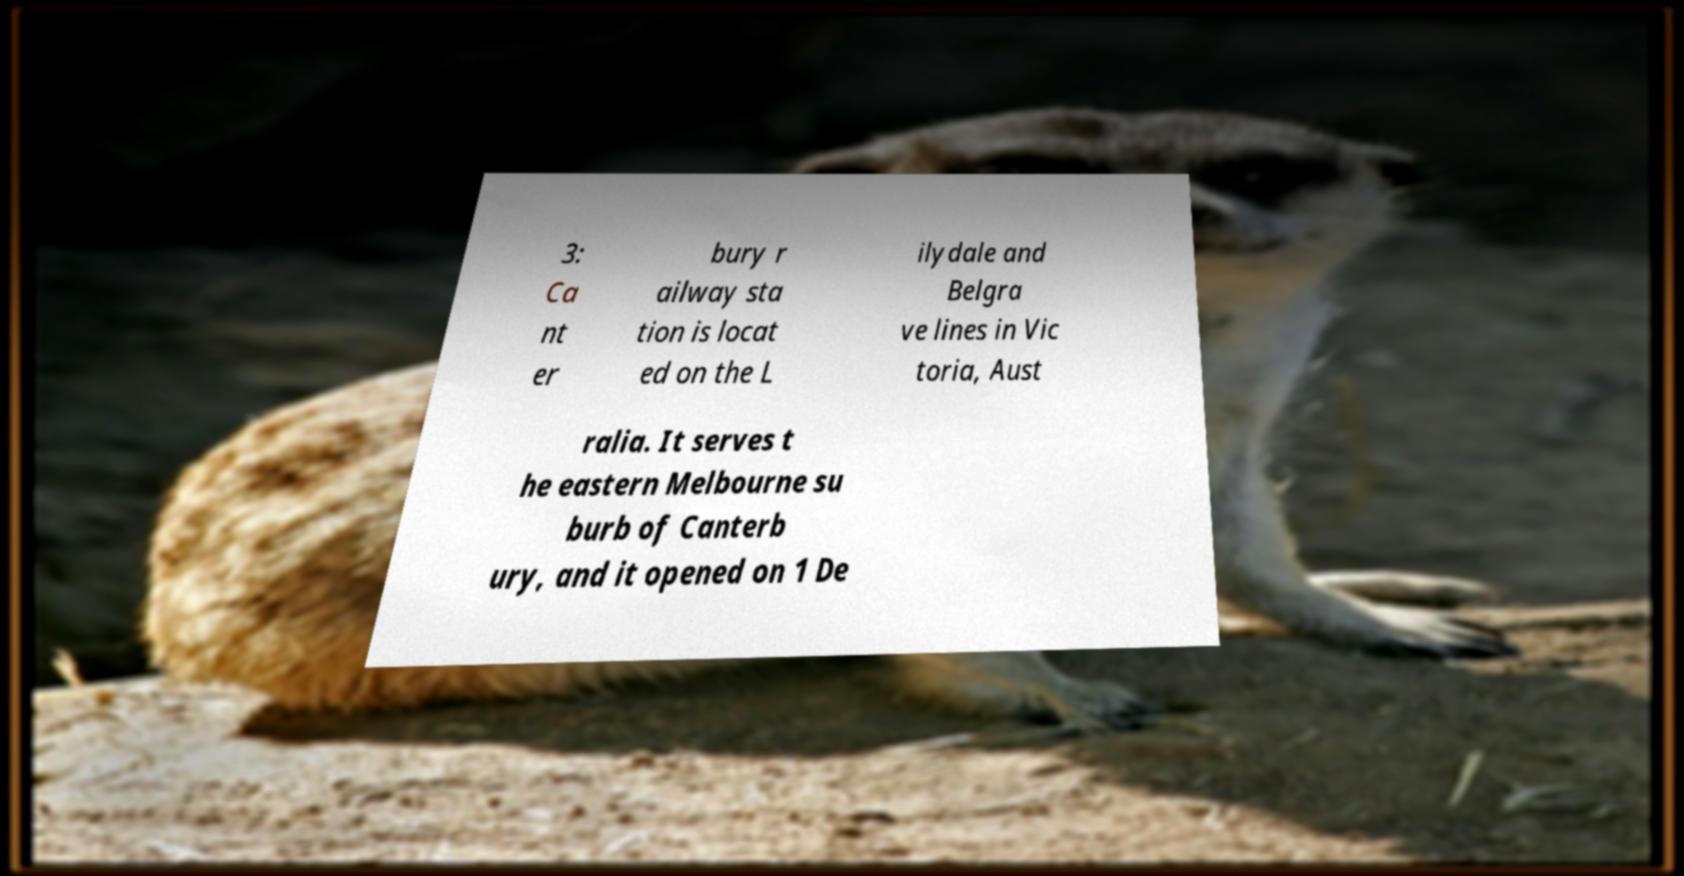For documentation purposes, I need the text within this image transcribed. Could you provide that? 3: Ca nt er bury r ailway sta tion is locat ed on the L ilydale and Belgra ve lines in Vic toria, Aust ralia. It serves t he eastern Melbourne su burb of Canterb ury, and it opened on 1 De 